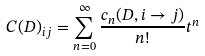<formula> <loc_0><loc_0><loc_500><loc_500>C ( D ) _ { i j } = \sum _ { n = 0 } ^ { \infty } \frac { c _ { n } ( D , i \rightarrow j ) } { n ! } t ^ { n }</formula> 